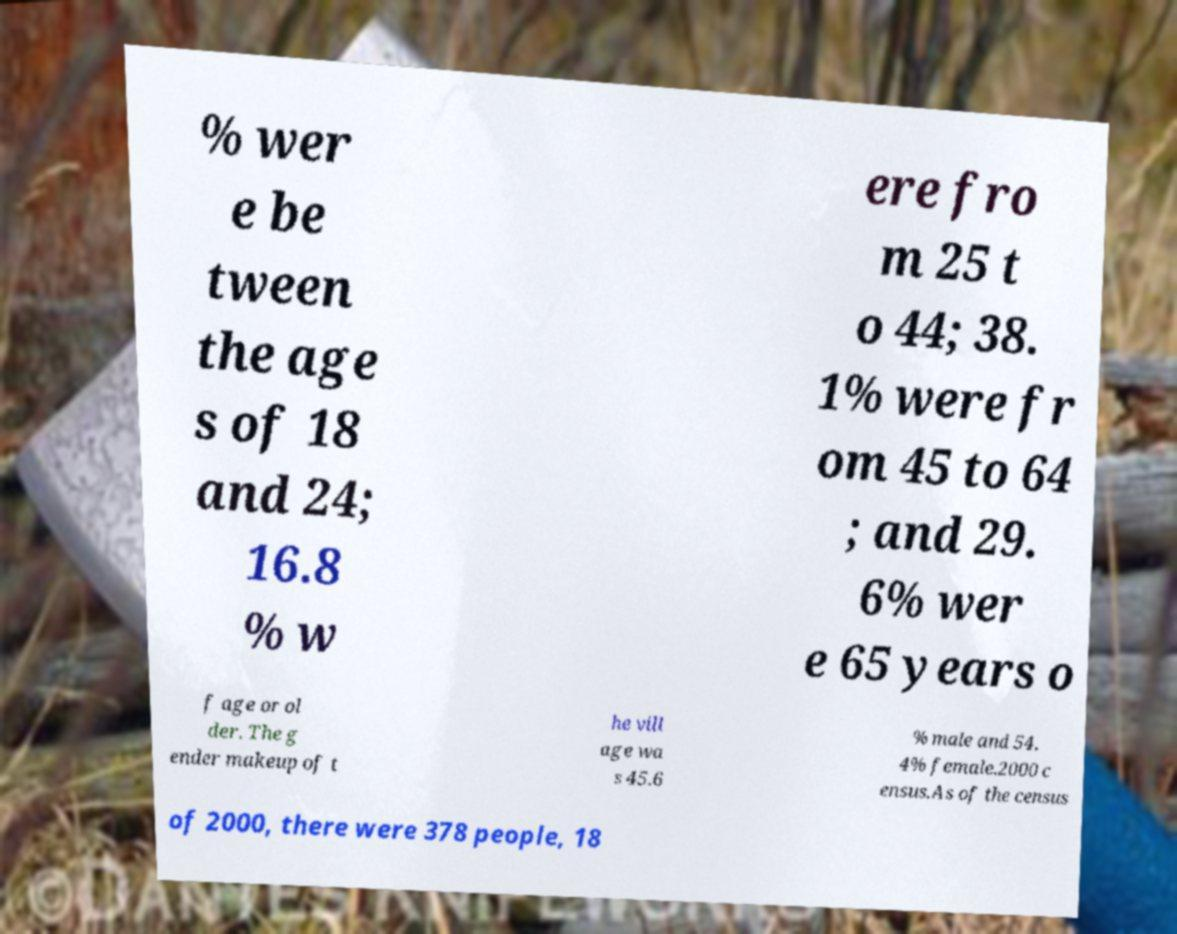Please read and relay the text visible in this image. What does it say? % wer e be tween the age s of 18 and 24; 16.8 % w ere fro m 25 t o 44; 38. 1% were fr om 45 to 64 ; and 29. 6% wer e 65 years o f age or ol der. The g ender makeup of t he vill age wa s 45.6 % male and 54. 4% female.2000 c ensus.As of the census of 2000, there were 378 people, 18 